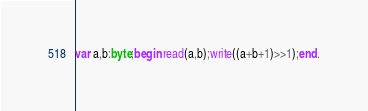<code> <loc_0><loc_0><loc_500><loc_500><_Pascal_>var a,b:byte;begin read(a,b);write((a+b+1)>>1);end.</code> 